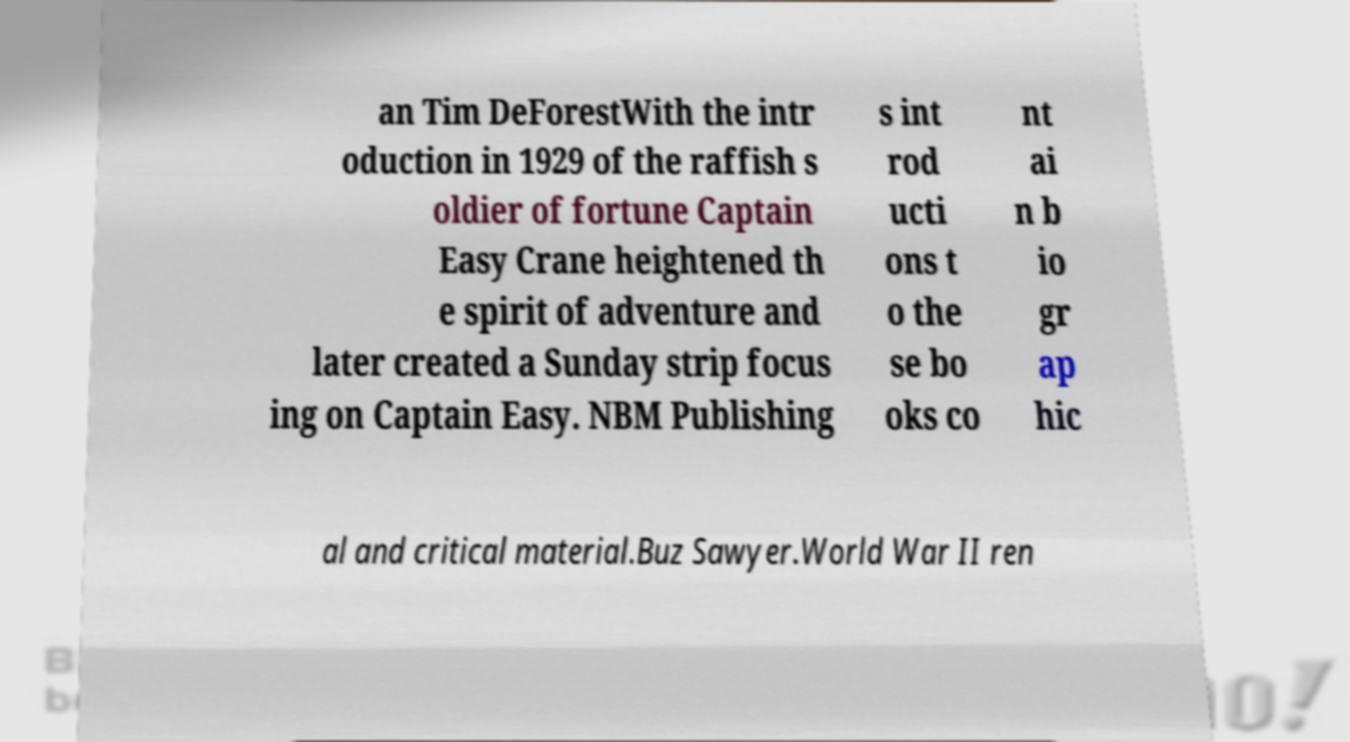Could you extract and type out the text from this image? an Tim DeForestWith the intr oduction in 1929 of the raffish s oldier of fortune Captain Easy Crane heightened th e spirit of adventure and later created a Sunday strip focus ing on Captain Easy. NBM Publishing s int rod ucti ons t o the se bo oks co nt ai n b io gr ap hic al and critical material.Buz Sawyer.World War II ren 